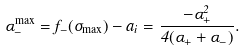Convert formula to latex. <formula><loc_0><loc_0><loc_500><loc_500>\alpha ^ { \max } _ { - } = f _ { - } ( \sigma _ { \max } ) - a _ { i } = \frac { - \alpha ^ { 2 } _ { + } } { 4 ( \alpha _ { + } + \alpha _ { - } ) } .</formula> 